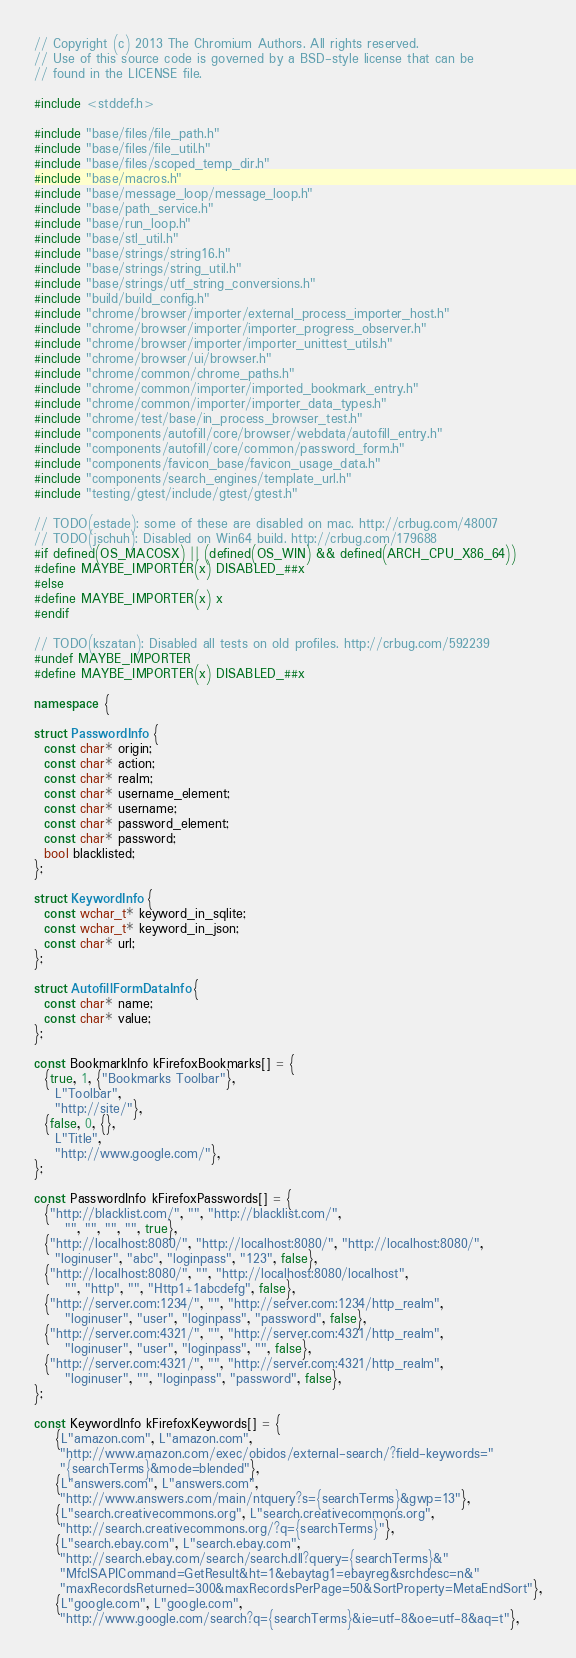<code> <loc_0><loc_0><loc_500><loc_500><_C++_>// Copyright (c) 2013 The Chromium Authors. All rights reserved.
// Use of this source code is governed by a BSD-style license that can be
// found in the LICENSE file.

#include <stddef.h>

#include "base/files/file_path.h"
#include "base/files/file_util.h"
#include "base/files/scoped_temp_dir.h"
#include "base/macros.h"
#include "base/message_loop/message_loop.h"
#include "base/path_service.h"
#include "base/run_loop.h"
#include "base/stl_util.h"
#include "base/strings/string16.h"
#include "base/strings/string_util.h"
#include "base/strings/utf_string_conversions.h"
#include "build/build_config.h"
#include "chrome/browser/importer/external_process_importer_host.h"
#include "chrome/browser/importer/importer_progress_observer.h"
#include "chrome/browser/importer/importer_unittest_utils.h"
#include "chrome/browser/ui/browser.h"
#include "chrome/common/chrome_paths.h"
#include "chrome/common/importer/imported_bookmark_entry.h"
#include "chrome/common/importer/importer_data_types.h"
#include "chrome/test/base/in_process_browser_test.h"
#include "components/autofill/core/browser/webdata/autofill_entry.h"
#include "components/autofill/core/common/password_form.h"
#include "components/favicon_base/favicon_usage_data.h"
#include "components/search_engines/template_url.h"
#include "testing/gtest/include/gtest/gtest.h"

// TODO(estade): some of these are disabled on mac. http://crbug.com/48007
// TODO(jschuh): Disabled on Win64 build. http://crbug.com/179688
#if defined(OS_MACOSX) || (defined(OS_WIN) && defined(ARCH_CPU_X86_64))
#define MAYBE_IMPORTER(x) DISABLED_##x
#else
#define MAYBE_IMPORTER(x) x
#endif

// TODO(kszatan): Disabled all tests on old profiles. http://crbug.com/592239
#undef MAYBE_IMPORTER
#define MAYBE_IMPORTER(x) DISABLED_##x

namespace {

struct PasswordInfo {
  const char* origin;
  const char* action;
  const char* realm;
  const char* username_element;
  const char* username;
  const char* password_element;
  const char* password;
  bool blacklisted;
};

struct KeywordInfo {
  const wchar_t* keyword_in_sqlite;
  const wchar_t* keyword_in_json;
  const char* url;
};

struct AutofillFormDataInfo {
  const char* name;
  const char* value;
};

const BookmarkInfo kFirefoxBookmarks[] = {
  {true, 1, {"Bookmarks Toolbar"},
    L"Toolbar",
    "http://site/"},
  {false, 0, {},
    L"Title",
    "http://www.google.com/"},
};

const PasswordInfo kFirefoxPasswords[] = {
  {"http://blacklist.com/", "", "http://blacklist.com/",
      "", "", "", "", true},
  {"http://localhost:8080/", "http://localhost:8080/", "http://localhost:8080/",
    "loginuser", "abc", "loginpass", "123", false},
  {"http://localhost:8080/", "", "http://localhost:8080/localhost",
      "", "http", "", "Http1+1abcdefg", false},
  {"http://server.com:1234/", "", "http://server.com:1234/http_realm",
      "loginuser", "user", "loginpass", "password", false},
  {"http://server.com:4321/", "", "http://server.com:4321/http_realm",
      "loginuser", "user", "loginpass", "", false},
  {"http://server.com:4321/", "", "http://server.com:4321/http_realm",
      "loginuser", "", "loginpass", "password", false},
};

const KeywordInfo kFirefoxKeywords[] = {
    {L"amazon.com", L"amazon.com",
     "http://www.amazon.com/exec/obidos/external-search/?field-keywords="
     "{searchTerms}&mode=blended"},
    {L"answers.com", L"answers.com",
     "http://www.answers.com/main/ntquery?s={searchTerms}&gwp=13"},
    {L"search.creativecommons.org", L"search.creativecommons.org",
     "http://search.creativecommons.org/?q={searchTerms}"},
    {L"search.ebay.com", L"search.ebay.com",
     "http://search.ebay.com/search/search.dll?query={searchTerms}&"
     "MfcISAPICommand=GetResult&ht=1&ebaytag1=ebayreg&srchdesc=n&"
     "maxRecordsReturned=300&maxRecordsPerPage=50&SortProperty=MetaEndSort"},
    {L"google.com", L"google.com",
     "http://www.google.com/search?q={searchTerms}&ie=utf-8&oe=utf-8&aq=t"},</code> 